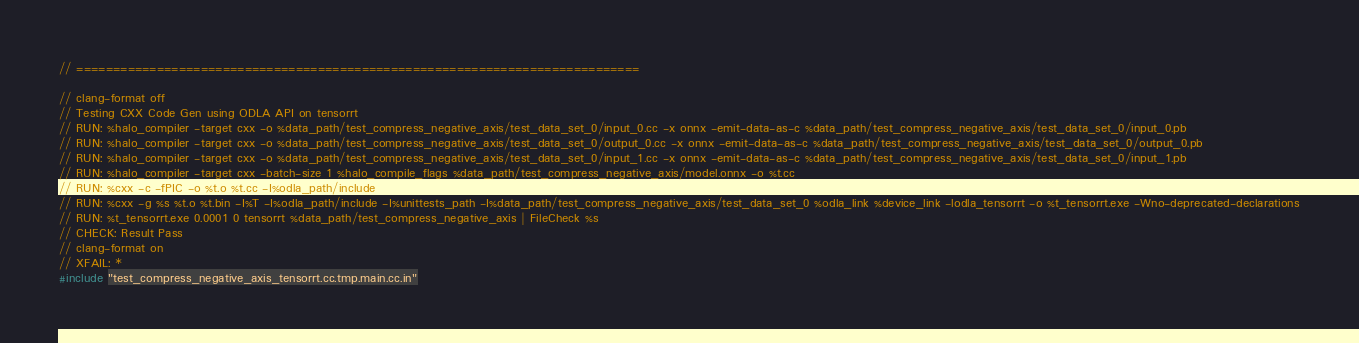<code> <loc_0><loc_0><loc_500><loc_500><_C++_>// =============================================================================

// clang-format off
// Testing CXX Code Gen using ODLA API on tensorrt
// RUN: %halo_compiler -target cxx -o %data_path/test_compress_negative_axis/test_data_set_0/input_0.cc -x onnx -emit-data-as-c %data_path/test_compress_negative_axis/test_data_set_0/input_0.pb
// RUN: %halo_compiler -target cxx -o %data_path/test_compress_negative_axis/test_data_set_0/output_0.cc -x onnx -emit-data-as-c %data_path/test_compress_negative_axis/test_data_set_0/output_0.pb
// RUN: %halo_compiler -target cxx -o %data_path/test_compress_negative_axis/test_data_set_0/input_1.cc -x onnx -emit-data-as-c %data_path/test_compress_negative_axis/test_data_set_0/input_1.pb
// RUN: %halo_compiler -target cxx -batch-size 1 %halo_compile_flags %data_path/test_compress_negative_axis/model.onnx -o %t.cc
// RUN: %cxx -c -fPIC -o %t.o %t.cc -I%odla_path/include
// RUN: %cxx -g %s %t.o %t.bin -I%T -I%odla_path/include -I%unittests_path -I%data_path/test_compress_negative_axis/test_data_set_0 %odla_link %device_link -lodla_tensorrt -o %t_tensorrt.exe -Wno-deprecated-declarations
// RUN: %t_tensorrt.exe 0.0001 0 tensorrt %data_path/test_compress_negative_axis | FileCheck %s
// CHECK: Result Pass
// clang-format on
// XFAIL: *
#include "test_compress_negative_axis_tensorrt.cc.tmp.main.cc.in"
</code> 